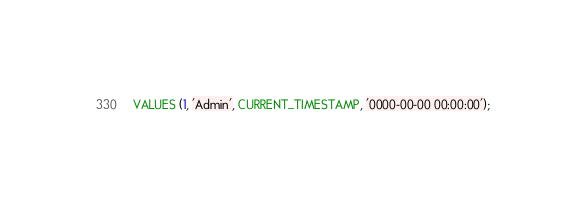<code> <loc_0><loc_0><loc_500><loc_500><_SQL_>VALUES (1, 'Admin', CURRENT_TIMESTAMP, '0000-00-00 00:00:00');</code> 